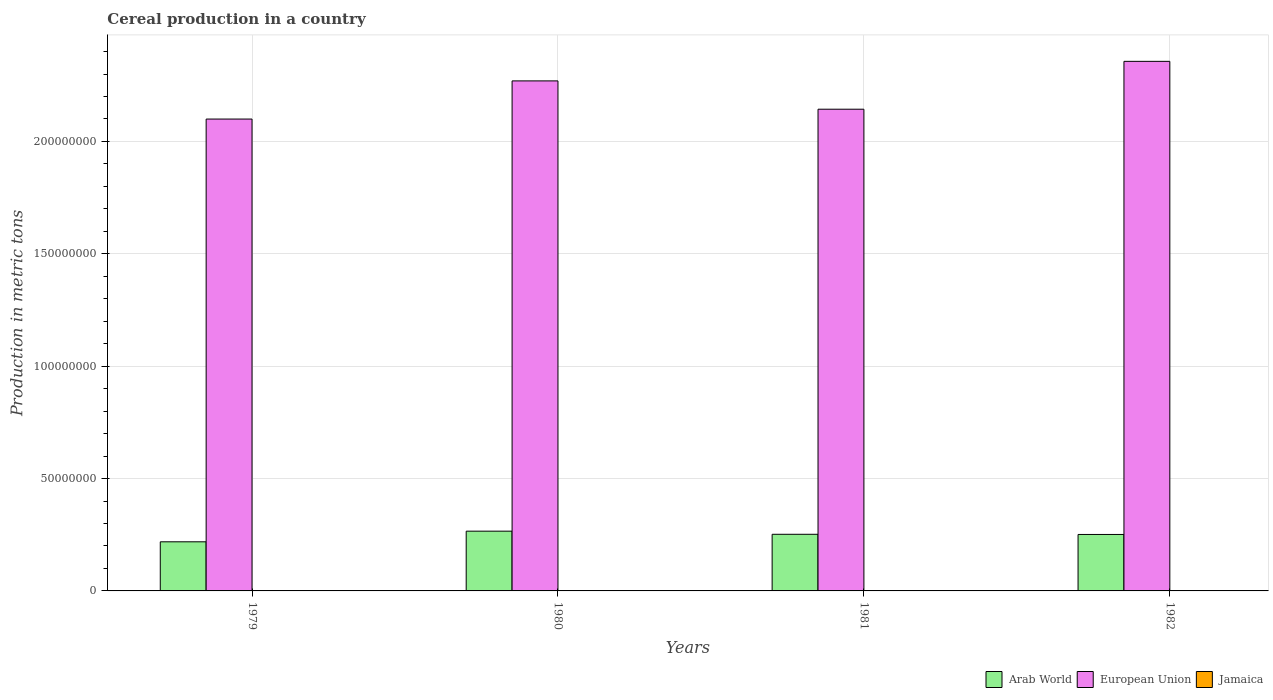How many different coloured bars are there?
Provide a succinct answer. 3. How many groups of bars are there?
Offer a very short reply. 4. How many bars are there on the 1st tick from the left?
Your response must be concise. 3. What is the total cereal production in Jamaica in 1981?
Your answer should be compact. 6374. Across all years, what is the maximum total cereal production in European Union?
Your response must be concise. 2.36e+08. Across all years, what is the minimum total cereal production in European Union?
Your answer should be very brief. 2.10e+08. In which year was the total cereal production in Jamaica maximum?
Offer a terse response. 1979. In which year was the total cereal production in Arab World minimum?
Provide a succinct answer. 1979. What is the total total cereal production in Jamaica in the graph?
Make the answer very short. 2.51e+04. What is the difference between the total cereal production in European Union in 1979 and that in 1980?
Provide a succinct answer. -1.70e+07. What is the difference between the total cereal production in European Union in 1982 and the total cereal production in Jamaica in 1980?
Your response must be concise. 2.36e+08. What is the average total cereal production in Jamaica per year?
Keep it short and to the point. 6273.75. In the year 1980, what is the difference between the total cereal production in Jamaica and total cereal production in Arab World?
Keep it short and to the point. -2.66e+07. What is the ratio of the total cereal production in Jamaica in 1979 to that in 1980?
Your answer should be compact. 1.08. Is the total cereal production in Jamaica in 1979 less than that in 1982?
Keep it short and to the point. No. Is the difference between the total cereal production in Jamaica in 1980 and 1981 greater than the difference between the total cereal production in Arab World in 1980 and 1981?
Offer a terse response. No. What is the difference between the highest and the second highest total cereal production in European Union?
Provide a succinct answer. 8.70e+06. What is the difference between the highest and the lowest total cereal production in Arab World?
Your answer should be compact. 4.74e+06. What does the 2nd bar from the left in 1982 represents?
Your answer should be compact. European Union. What does the 1st bar from the right in 1979 represents?
Keep it short and to the point. Jamaica. How many bars are there?
Your answer should be very brief. 12. How many years are there in the graph?
Ensure brevity in your answer.  4. Does the graph contain any zero values?
Provide a succinct answer. No. How many legend labels are there?
Provide a short and direct response. 3. What is the title of the graph?
Ensure brevity in your answer.  Cereal production in a country. What is the label or title of the Y-axis?
Provide a short and direct response. Production in metric tons. What is the Production in metric tons of Arab World in 1979?
Give a very brief answer. 2.19e+07. What is the Production in metric tons in European Union in 1979?
Your answer should be very brief. 2.10e+08. What is the Production in metric tons in Jamaica in 1979?
Your answer should be very brief. 7309. What is the Production in metric tons of Arab World in 1980?
Your answer should be very brief. 2.66e+07. What is the Production in metric tons of European Union in 1980?
Ensure brevity in your answer.  2.27e+08. What is the Production in metric tons in Jamaica in 1980?
Ensure brevity in your answer.  6782. What is the Production in metric tons in Arab World in 1981?
Give a very brief answer. 2.52e+07. What is the Production in metric tons of European Union in 1981?
Offer a very short reply. 2.14e+08. What is the Production in metric tons of Jamaica in 1981?
Your response must be concise. 6374. What is the Production in metric tons of Arab World in 1982?
Offer a very short reply. 2.51e+07. What is the Production in metric tons in European Union in 1982?
Provide a short and direct response. 2.36e+08. What is the Production in metric tons of Jamaica in 1982?
Your answer should be compact. 4630. Across all years, what is the maximum Production in metric tons of Arab World?
Your answer should be very brief. 2.66e+07. Across all years, what is the maximum Production in metric tons in European Union?
Provide a short and direct response. 2.36e+08. Across all years, what is the maximum Production in metric tons in Jamaica?
Offer a terse response. 7309. Across all years, what is the minimum Production in metric tons in Arab World?
Provide a succinct answer. 2.19e+07. Across all years, what is the minimum Production in metric tons of European Union?
Your answer should be very brief. 2.10e+08. Across all years, what is the minimum Production in metric tons of Jamaica?
Provide a succinct answer. 4630. What is the total Production in metric tons in Arab World in the graph?
Make the answer very short. 9.88e+07. What is the total Production in metric tons in European Union in the graph?
Offer a very short reply. 8.87e+08. What is the total Production in metric tons in Jamaica in the graph?
Ensure brevity in your answer.  2.51e+04. What is the difference between the Production in metric tons of Arab World in 1979 and that in 1980?
Your answer should be very brief. -4.74e+06. What is the difference between the Production in metric tons of European Union in 1979 and that in 1980?
Keep it short and to the point. -1.70e+07. What is the difference between the Production in metric tons in Jamaica in 1979 and that in 1980?
Your answer should be very brief. 527. What is the difference between the Production in metric tons of Arab World in 1979 and that in 1981?
Offer a terse response. -3.34e+06. What is the difference between the Production in metric tons in European Union in 1979 and that in 1981?
Offer a very short reply. -4.38e+06. What is the difference between the Production in metric tons in Jamaica in 1979 and that in 1981?
Offer a very short reply. 935. What is the difference between the Production in metric tons in Arab World in 1979 and that in 1982?
Provide a short and direct response. -3.27e+06. What is the difference between the Production in metric tons in European Union in 1979 and that in 1982?
Your answer should be very brief. -2.57e+07. What is the difference between the Production in metric tons of Jamaica in 1979 and that in 1982?
Make the answer very short. 2679. What is the difference between the Production in metric tons of Arab World in 1980 and that in 1981?
Offer a very short reply. 1.40e+06. What is the difference between the Production in metric tons in European Union in 1980 and that in 1981?
Ensure brevity in your answer.  1.26e+07. What is the difference between the Production in metric tons of Jamaica in 1980 and that in 1981?
Offer a very short reply. 408. What is the difference between the Production in metric tons in Arab World in 1980 and that in 1982?
Make the answer very short. 1.47e+06. What is the difference between the Production in metric tons of European Union in 1980 and that in 1982?
Offer a very short reply. -8.70e+06. What is the difference between the Production in metric tons in Jamaica in 1980 and that in 1982?
Your response must be concise. 2152. What is the difference between the Production in metric tons in Arab World in 1981 and that in 1982?
Provide a succinct answer. 7.64e+04. What is the difference between the Production in metric tons in European Union in 1981 and that in 1982?
Offer a very short reply. -2.13e+07. What is the difference between the Production in metric tons of Jamaica in 1981 and that in 1982?
Provide a short and direct response. 1744. What is the difference between the Production in metric tons in Arab World in 1979 and the Production in metric tons in European Union in 1980?
Make the answer very short. -2.05e+08. What is the difference between the Production in metric tons of Arab World in 1979 and the Production in metric tons of Jamaica in 1980?
Keep it short and to the point. 2.18e+07. What is the difference between the Production in metric tons of European Union in 1979 and the Production in metric tons of Jamaica in 1980?
Offer a very short reply. 2.10e+08. What is the difference between the Production in metric tons of Arab World in 1979 and the Production in metric tons of European Union in 1981?
Your answer should be very brief. -1.92e+08. What is the difference between the Production in metric tons of Arab World in 1979 and the Production in metric tons of Jamaica in 1981?
Provide a succinct answer. 2.18e+07. What is the difference between the Production in metric tons of European Union in 1979 and the Production in metric tons of Jamaica in 1981?
Offer a terse response. 2.10e+08. What is the difference between the Production in metric tons of Arab World in 1979 and the Production in metric tons of European Union in 1982?
Provide a succinct answer. -2.14e+08. What is the difference between the Production in metric tons in Arab World in 1979 and the Production in metric tons in Jamaica in 1982?
Keep it short and to the point. 2.18e+07. What is the difference between the Production in metric tons in European Union in 1979 and the Production in metric tons in Jamaica in 1982?
Provide a succinct answer. 2.10e+08. What is the difference between the Production in metric tons of Arab World in 1980 and the Production in metric tons of European Union in 1981?
Make the answer very short. -1.88e+08. What is the difference between the Production in metric tons in Arab World in 1980 and the Production in metric tons in Jamaica in 1981?
Provide a short and direct response. 2.66e+07. What is the difference between the Production in metric tons in European Union in 1980 and the Production in metric tons in Jamaica in 1981?
Make the answer very short. 2.27e+08. What is the difference between the Production in metric tons in Arab World in 1980 and the Production in metric tons in European Union in 1982?
Offer a terse response. -2.09e+08. What is the difference between the Production in metric tons in Arab World in 1980 and the Production in metric tons in Jamaica in 1982?
Your response must be concise. 2.66e+07. What is the difference between the Production in metric tons of European Union in 1980 and the Production in metric tons of Jamaica in 1982?
Make the answer very short. 2.27e+08. What is the difference between the Production in metric tons of Arab World in 1981 and the Production in metric tons of European Union in 1982?
Ensure brevity in your answer.  -2.10e+08. What is the difference between the Production in metric tons of Arab World in 1981 and the Production in metric tons of Jamaica in 1982?
Provide a succinct answer. 2.52e+07. What is the difference between the Production in metric tons in European Union in 1981 and the Production in metric tons in Jamaica in 1982?
Offer a very short reply. 2.14e+08. What is the average Production in metric tons of Arab World per year?
Keep it short and to the point. 2.47e+07. What is the average Production in metric tons of European Union per year?
Provide a succinct answer. 2.22e+08. What is the average Production in metric tons of Jamaica per year?
Your answer should be compact. 6273.75. In the year 1979, what is the difference between the Production in metric tons in Arab World and Production in metric tons in European Union?
Ensure brevity in your answer.  -1.88e+08. In the year 1979, what is the difference between the Production in metric tons of Arab World and Production in metric tons of Jamaica?
Give a very brief answer. 2.18e+07. In the year 1979, what is the difference between the Production in metric tons in European Union and Production in metric tons in Jamaica?
Provide a succinct answer. 2.10e+08. In the year 1980, what is the difference between the Production in metric tons in Arab World and Production in metric tons in European Union?
Ensure brevity in your answer.  -2.00e+08. In the year 1980, what is the difference between the Production in metric tons in Arab World and Production in metric tons in Jamaica?
Ensure brevity in your answer.  2.66e+07. In the year 1980, what is the difference between the Production in metric tons in European Union and Production in metric tons in Jamaica?
Offer a terse response. 2.27e+08. In the year 1981, what is the difference between the Production in metric tons in Arab World and Production in metric tons in European Union?
Your answer should be compact. -1.89e+08. In the year 1981, what is the difference between the Production in metric tons in Arab World and Production in metric tons in Jamaica?
Your response must be concise. 2.52e+07. In the year 1981, what is the difference between the Production in metric tons in European Union and Production in metric tons in Jamaica?
Offer a terse response. 2.14e+08. In the year 1982, what is the difference between the Production in metric tons in Arab World and Production in metric tons in European Union?
Provide a succinct answer. -2.11e+08. In the year 1982, what is the difference between the Production in metric tons in Arab World and Production in metric tons in Jamaica?
Offer a terse response. 2.51e+07. In the year 1982, what is the difference between the Production in metric tons in European Union and Production in metric tons in Jamaica?
Give a very brief answer. 2.36e+08. What is the ratio of the Production in metric tons of Arab World in 1979 to that in 1980?
Make the answer very short. 0.82. What is the ratio of the Production in metric tons in European Union in 1979 to that in 1980?
Offer a terse response. 0.93. What is the ratio of the Production in metric tons of Jamaica in 1979 to that in 1980?
Make the answer very short. 1.08. What is the ratio of the Production in metric tons in Arab World in 1979 to that in 1981?
Your answer should be very brief. 0.87. What is the ratio of the Production in metric tons in European Union in 1979 to that in 1981?
Keep it short and to the point. 0.98. What is the ratio of the Production in metric tons in Jamaica in 1979 to that in 1981?
Offer a very short reply. 1.15. What is the ratio of the Production in metric tons in Arab World in 1979 to that in 1982?
Keep it short and to the point. 0.87. What is the ratio of the Production in metric tons in European Union in 1979 to that in 1982?
Ensure brevity in your answer.  0.89. What is the ratio of the Production in metric tons in Jamaica in 1979 to that in 1982?
Your answer should be very brief. 1.58. What is the ratio of the Production in metric tons of Arab World in 1980 to that in 1981?
Your answer should be compact. 1.06. What is the ratio of the Production in metric tons of European Union in 1980 to that in 1981?
Offer a very short reply. 1.06. What is the ratio of the Production in metric tons of Jamaica in 1980 to that in 1981?
Keep it short and to the point. 1.06. What is the ratio of the Production in metric tons in Arab World in 1980 to that in 1982?
Your answer should be very brief. 1.06. What is the ratio of the Production in metric tons in European Union in 1980 to that in 1982?
Your answer should be very brief. 0.96. What is the ratio of the Production in metric tons of Jamaica in 1980 to that in 1982?
Offer a terse response. 1.46. What is the ratio of the Production in metric tons in Arab World in 1981 to that in 1982?
Your answer should be compact. 1. What is the ratio of the Production in metric tons in European Union in 1981 to that in 1982?
Ensure brevity in your answer.  0.91. What is the ratio of the Production in metric tons in Jamaica in 1981 to that in 1982?
Give a very brief answer. 1.38. What is the difference between the highest and the second highest Production in metric tons in Arab World?
Offer a very short reply. 1.40e+06. What is the difference between the highest and the second highest Production in metric tons of European Union?
Provide a succinct answer. 8.70e+06. What is the difference between the highest and the second highest Production in metric tons of Jamaica?
Offer a very short reply. 527. What is the difference between the highest and the lowest Production in metric tons in Arab World?
Keep it short and to the point. 4.74e+06. What is the difference between the highest and the lowest Production in metric tons in European Union?
Keep it short and to the point. 2.57e+07. What is the difference between the highest and the lowest Production in metric tons of Jamaica?
Provide a succinct answer. 2679. 